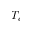<formula> <loc_0><loc_0><loc_500><loc_500>T _ { c }</formula> 